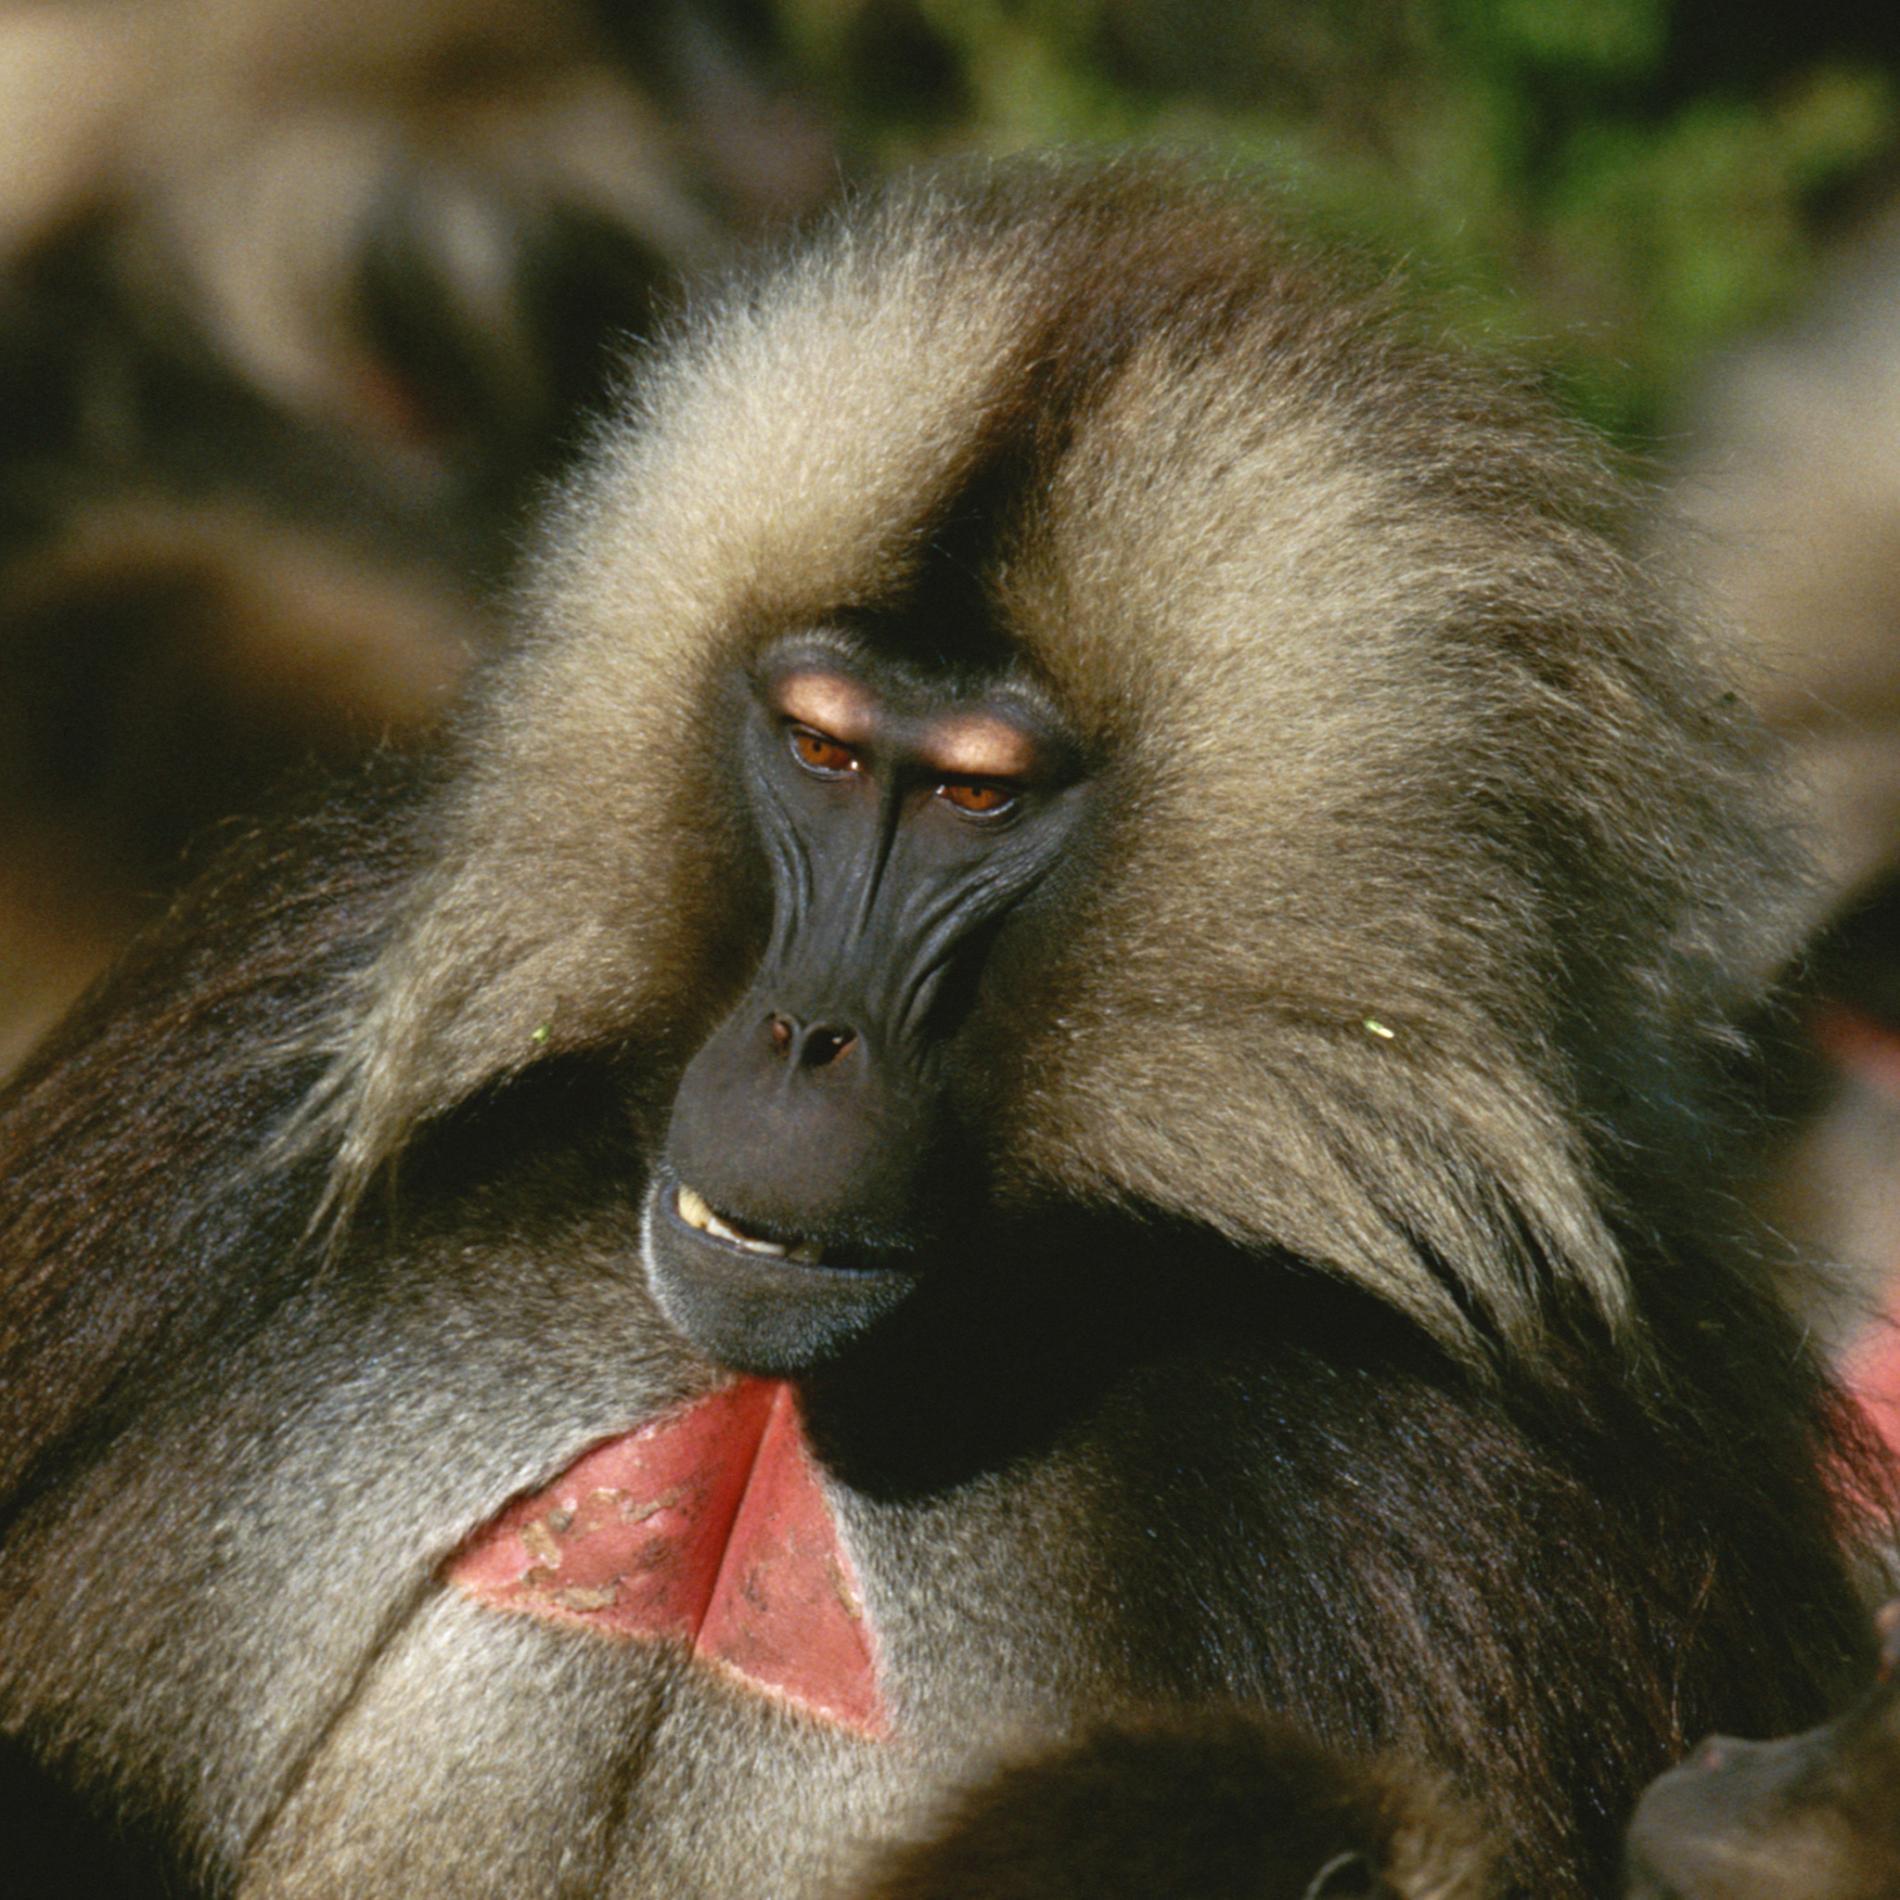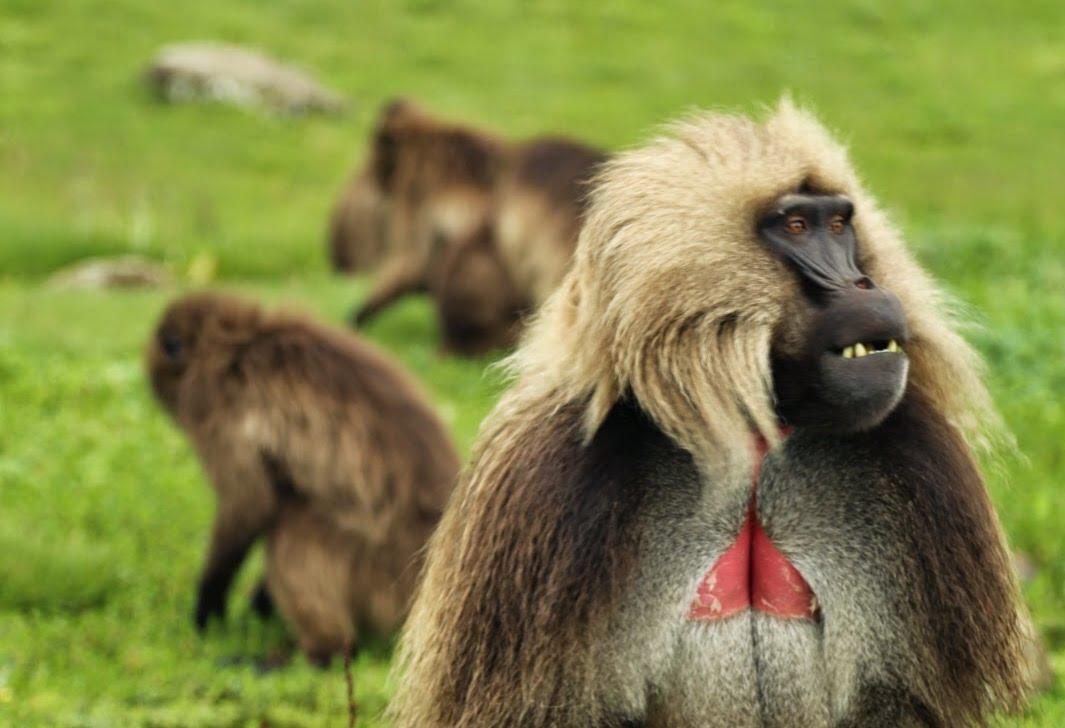The first image is the image on the left, the second image is the image on the right. Assess this claim about the two images: "At least one baboon has a wide open mouth.". Correct or not? Answer yes or no. No. The first image is the image on the left, the second image is the image on the right. Evaluate the accuracy of this statement regarding the images: "in the right pic the primates fangs are fully shown". Is it true? Answer yes or no. No. 